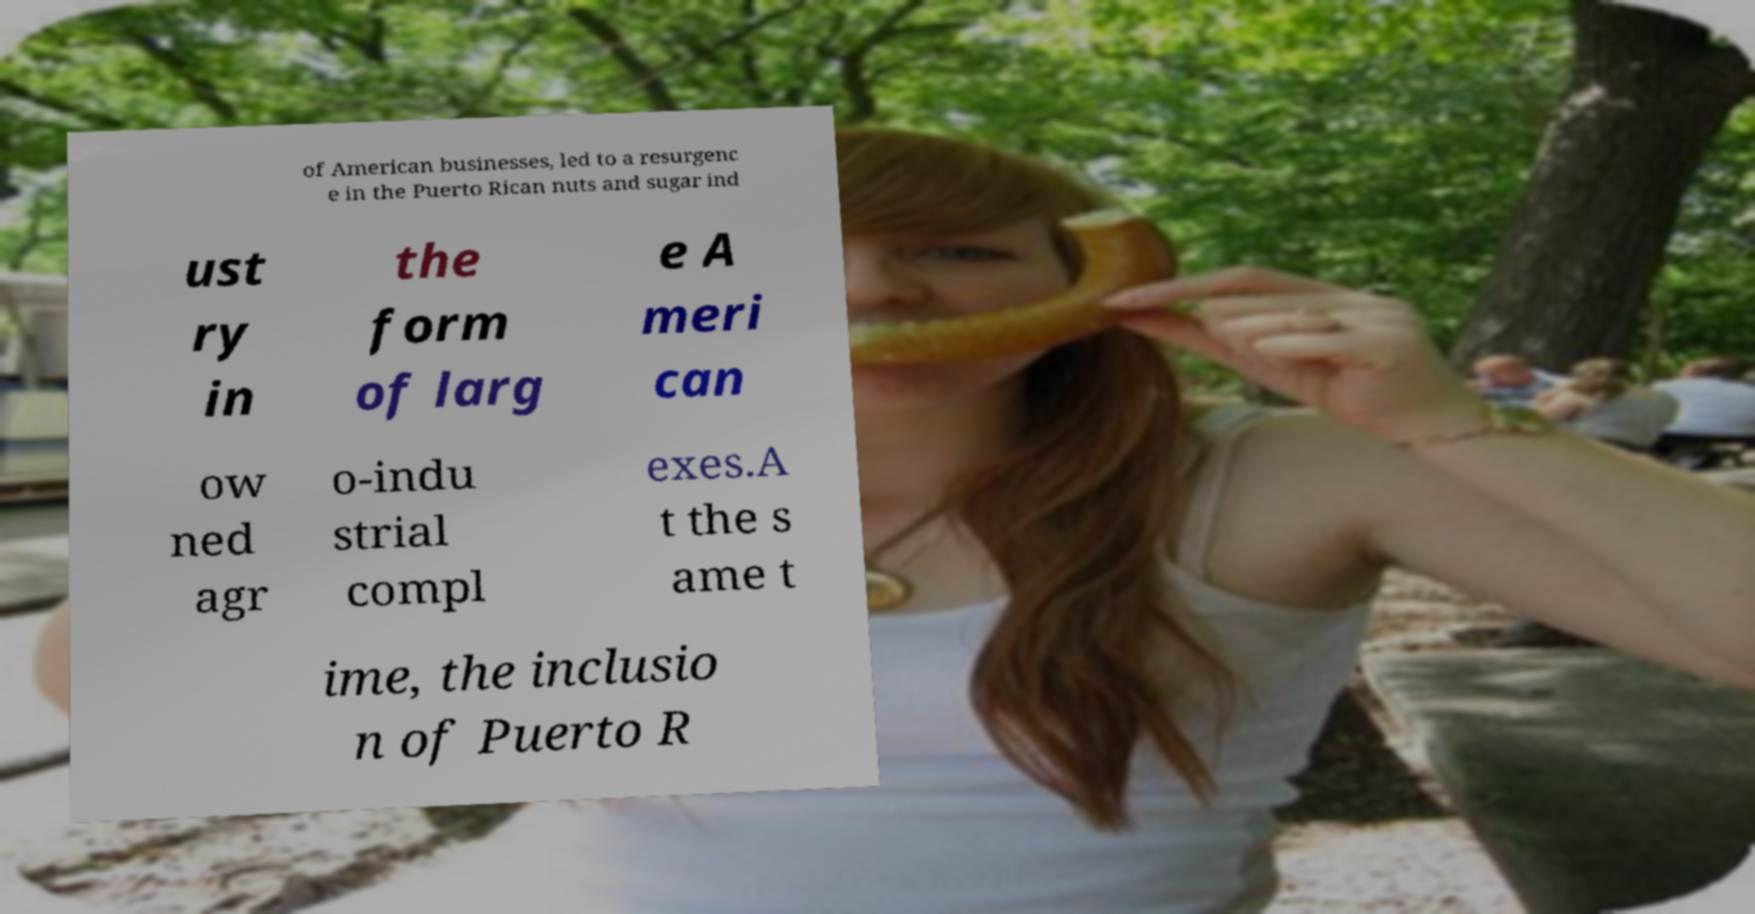Please identify and transcribe the text found in this image. of American businesses, led to a resurgenc e in the Puerto Rican nuts and sugar ind ust ry in the form of larg e A meri can ow ned agr o-indu strial compl exes.A t the s ame t ime, the inclusio n of Puerto R 